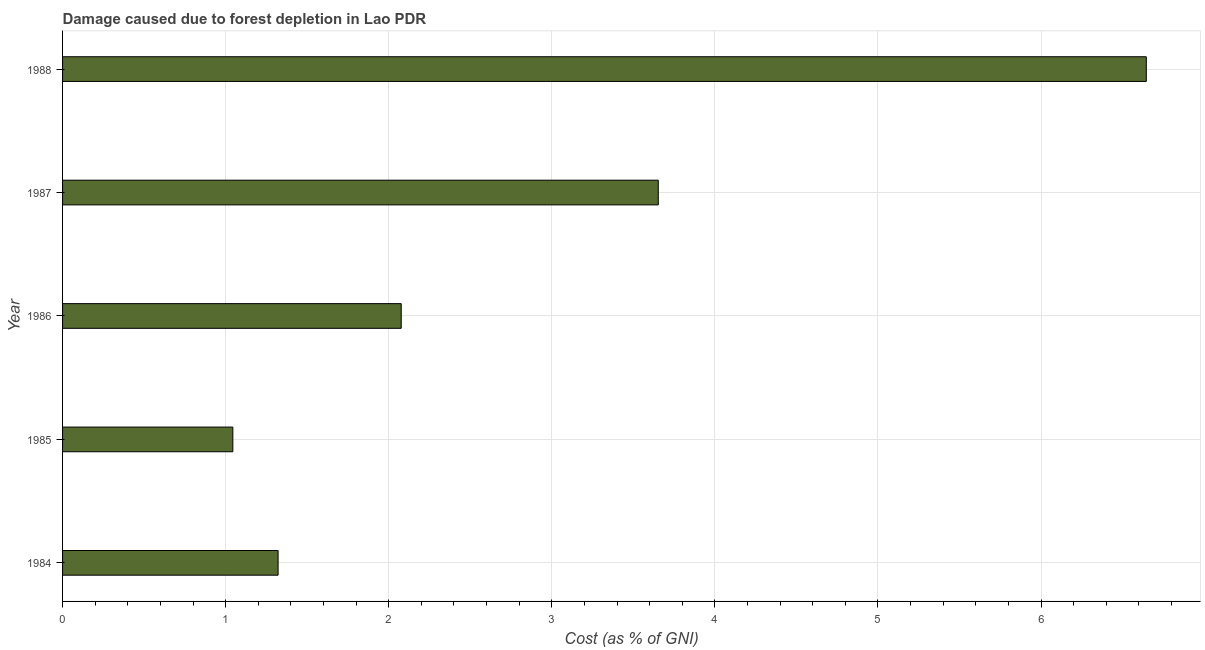Does the graph contain any zero values?
Provide a succinct answer. No. What is the title of the graph?
Keep it short and to the point. Damage caused due to forest depletion in Lao PDR. What is the label or title of the X-axis?
Your answer should be very brief. Cost (as % of GNI). What is the label or title of the Y-axis?
Your response must be concise. Year. What is the damage caused due to forest depletion in 1984?
Your answer should be very brief. 1.32. Across all years, what is the maximum damage caused due to forest depletion?
Ensure brevity in your answer.  6.65. Across all years, what is the minimum damage caused due to forest depletion?
Offer a terse response. 1.04. In which year was the damage caused due to forest depletion maximum?
Your response must be concise. 1988. In which year was the damage caused due to forest depletion minimum?
Keep it short and to the point. 1985. What is the sum of the damage caused due to forest depletion?
Ensure brevity in your answer.  14.74. What is the difference between the damage caused due to forest depletion in 1984 and 1987?
Your response must be concise. -2.33. What is the average damage caused due to forest depletion per year?
Ensure brevity in your answer.  2.95. What is the median damage caused due to forest depletion?
Provide a short and direct response. 2.08. What is the ratio of the damage caused due to forest depletion in 1987 to that in 1988?
Your answer should be compact. 0.55. Is the damage caused due to forest depletion in 1985 less than that in 1986?
Give a very brief answer. Yes. What is the difference between the highest and the second highest damage caused due to forest depletion?
Keep it short and to the point. 2.99. How many bars are there?
Give a very brief answer. 5. Are the values on the major ticks of X-axis written in scientific E-notation?
Provide a short and direct response. No. What is the Cost (as % of GNI) of 1984?
Ensure brevity in your answer.  1.32. What is the Cost (as % of GNI) in 1985?
Make the answer very short. 1.04. What is the Cost (as % of GNI) of 1986?
Your answer should be very brief. 2.08. What is the Cost (as % of GNI) of 1987?
Your answer should be compact. 3.65. What is the Cost (as % of GNI) of 1988?
Offer a very short reply. 6.65. What is the difference between the Cost (as % of GNI) in 1984 and 1985?
Your response must be concise. 0.28. What is the difference between the Cost (as % of GNI) in 1984 and 1986?
Your answer should be very brief. -0.75. What is the difference between the Cost (as % of GNI) in 1984 and 1987?
Your answer should be very brief. -2.33. What is the difference between the Cost (as % of GNI) in 1984 and 1988?
Ensure brevity in your answer.  -5.32. What is the difference between the Cost (as % of GNI) in 1985 and 1986?
Provide a succinct answer. -1.03. What is the difference between the Cost (as % of GNI) in 1985 and 1987?
Offer a terse response. -2.61. What is the difference between the Cost (as % of GNI) in 1985 and 1988?
Offer a terse response. -5.6. What is the difference between the Cost (as % of GNI) in 1986 and 1987?
Provide a succinct answer. -1.58. What is the difference between the Cost (as % of GNI) in 1986 and 1988?
Provide a succinct answer. -4.57. What is the difference between the Cost (as % of GNI) in 1987 and 1988?
Keep it short and to the point. -2.99. What is the ratio of the Cost (as % of GNI) in 1984 to that in 1985?
Your response must be concise. 1.27. What is the ratio of the Cost (as % of GNI) in 1984 to that in 1986?
Your response must be concise. 0.64. What is the ratio of the Cost (as % of GNI) in 1984 to that in 1987?
Offer a very short reply. 0.36. What is the ratio of the Cost (as % of GNI) in 1984 to that in 1988?
Keep it short and to the point. 0.2. What is the ratio of the Cost (as % of GNI) in 1985 to that in 1986?
Offer a terse response. 0.5. What is the ratio of the Cost (as % of GNI) in 1985 to that in 1987?
Ensure brevity in your answer.  0.29. What is the ratio of the Cost (as % of GNI) in 1985 to that in 1988?
Your answer should be very brief. 0.16. What is the ratio of the Cost (as % of GNI) in 1986 to that in 1987?
Provide a succinct answer. 0.57. What is the ratio of the Cost (as % of GNI) in 1986 to that in 1988?
Ensure brevity in your answer.  0.31. What is the ratio of the Cost (as % of GNI) in 1987 to that in 1988?
Provide a succinct answer. 0.55. 